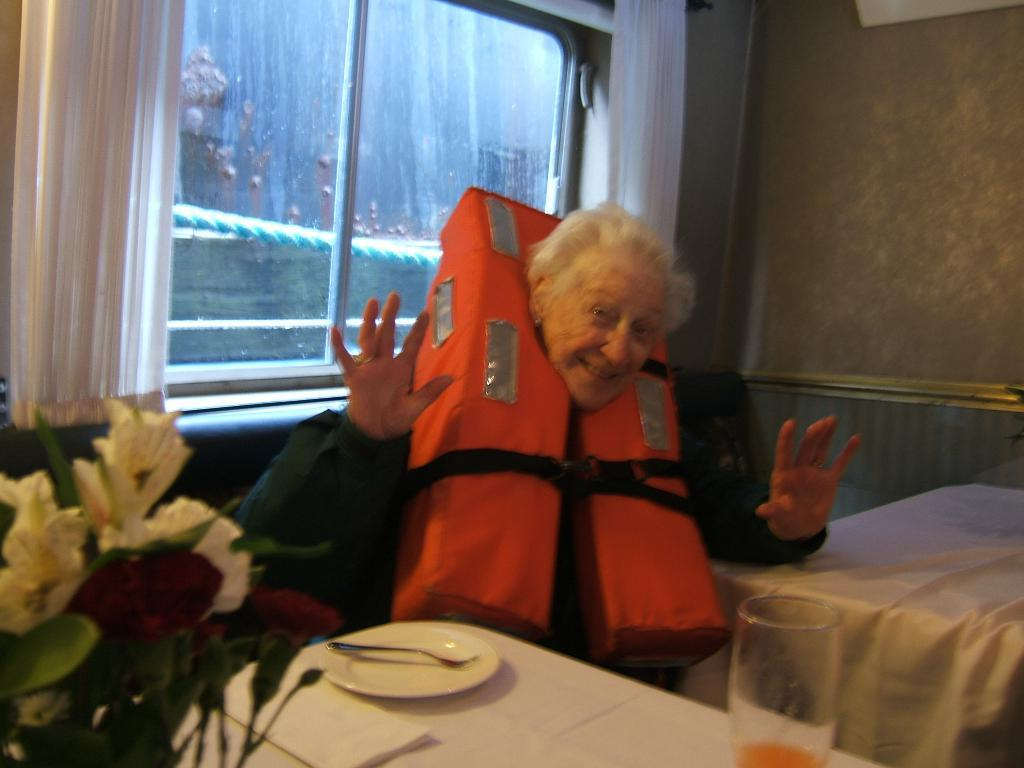Who is the main subject in the image? There is an old woman in the image. What is the old woman doing in the image? The old woman is sitting on a sofa. What can be seen behind the old woman? There is a glass window behind the old woman. What type of quince is being used to support the old woman's back in the image? There is no quince present in the image, and the old woman is not using any support for her back. 